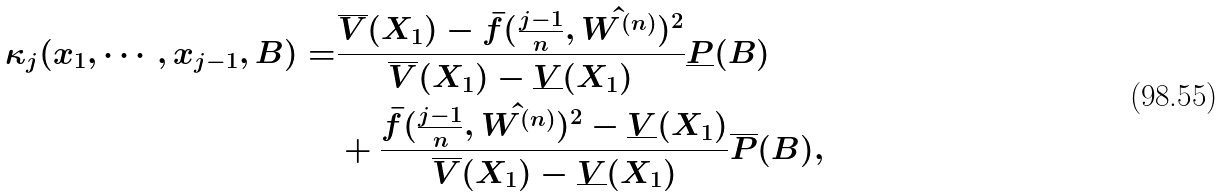Convert formula to latex. <formula><loc_0><loc_0><loc_500><loc_500>\kappa _ { j } ( x _ { 1 } , \cdots , x _ { j - 1 } , B ) = & \frac { \overline { V } ( X _ { 1 } ) - \bar { f } ( \frac { j - 1 } { n } , \hat { W ^ { ( n ) } } ) ^ { 2 } } { \overline { V } ( X _ { 1 } ) - \underline { V } ( X _ { 1 } ) } \underline { P } ( B ) \\ & + \frac { \bar { f } ( \frac { j - 1 } { n } , \hat { W ^ { ( n ) } } ) ^ { 2 } - \underline { V } ( X _ { 1 } ) } { \overline { V } ( X _ { 1 } ) - \underline { V } ( X _ { 1 } ) } \overline { P } ( B ) ,</formula> 